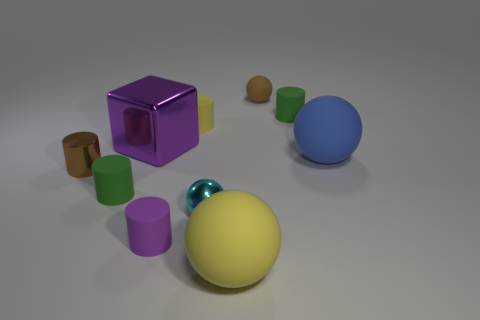Subtract 2 cylinders. How many cylinders are left? 3 Subtract all yellow cylinders. How many cylinders are left? 4 Subtract all green matte cylinders. How many cylinders are left? 3 Subtract all red spheres. Subtract all brown cylinders. How many spheres are left? 4 Subtract all cubes. How many objects are left? 9 Subtract all rubber cylinders. Subtract all big purple metallic cubes. How many objects are left? 5 Add 8 tiny green objects. How many tiny green objects are left? 10 Add 10 big matte cylinders. How many big matte cylinders exist? 10 Subtract 0 green cubes. How many objects are left? 10 